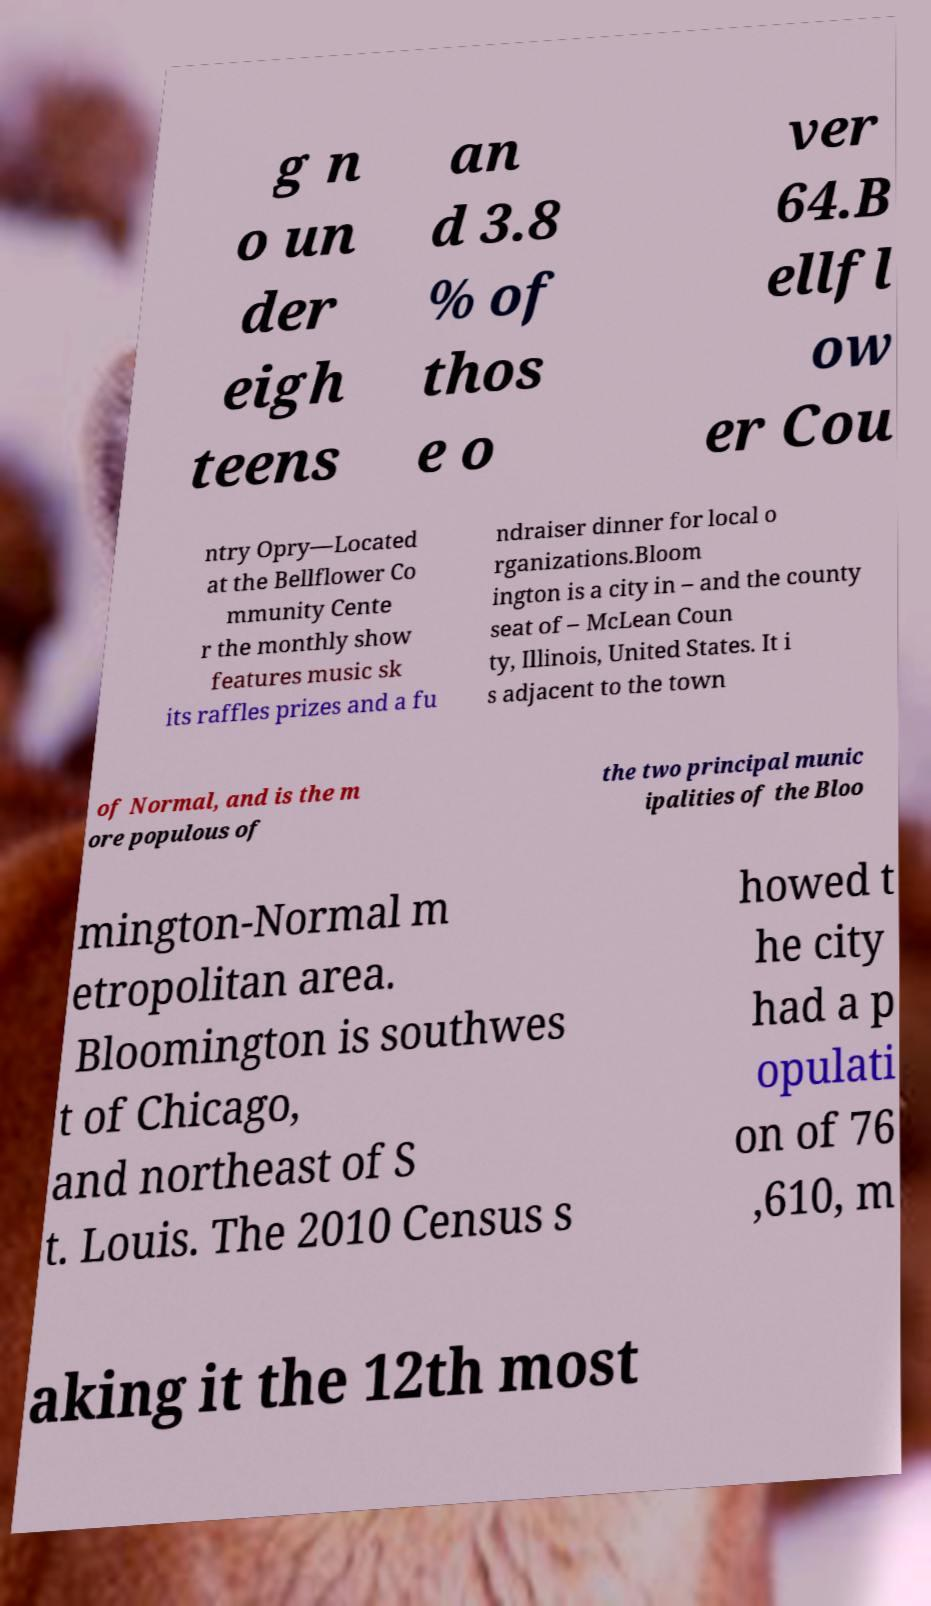For documentation purposes, I need the text within this image transcribed. Could you provide that? g n o un der eigh teens an d 3.8 % of thos e o ver 64.B ellfl ow er Cou ntry Opry—Located at the Bellflower Co mmunity Cente r the monthly show features music sk its raffles prizes and a fu ndraiser dinner for local o rganizations.Bloom ington is a city in – and the county seat of – McLean Coun ty, Illinois, United States. It i s adjacent to the town of Normal, and is the m ore populous of the two principal munic ipalities of the Bloo mington-Normal m etropolitan area. Bloomington is southwes t of Chicago, and northeast of S t. Louis. The 2010 Census s howed t he city had a p opulati on of 76 ,610, m aking it the 12th most 